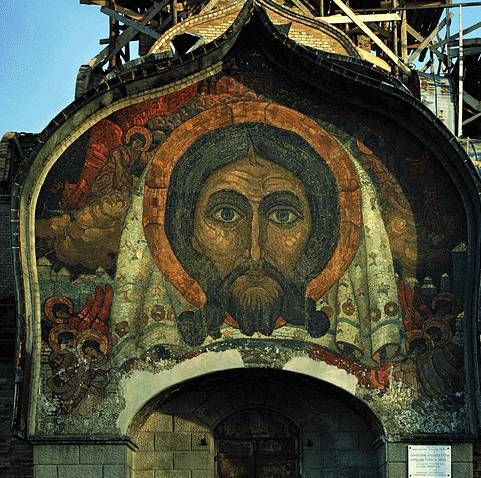What does the color palette used in this mosaic tell us about the period it was created? The rich color palette, featuring deep reds, golds, and greens, is highly characteristic of Byzantine mosaics and often reflects the religious and cultural significance of the period. Gold indicates divinity and light, often used to depict holy figures, symbolizing their heavenly nature. The reds might represent passion or martyrdom, while greens are typically associated with renewal. Such colors not only enhanced the spiritual impact of the piece but also demonstrated the technical prowess and artistic resources available during the time. 